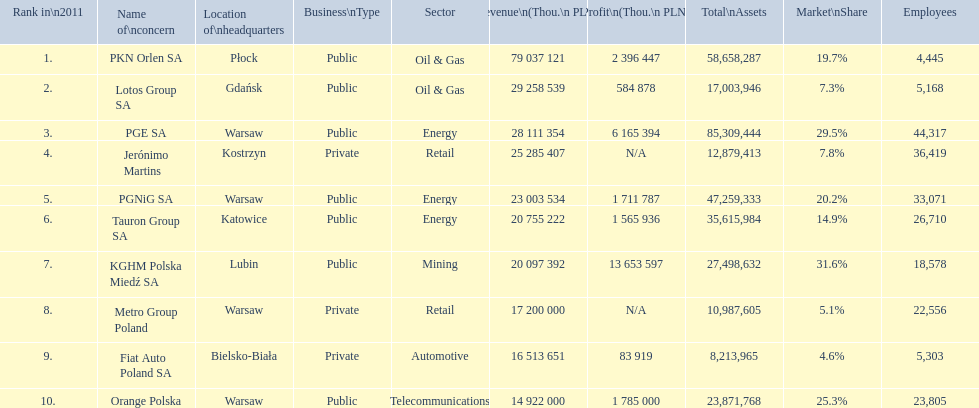What companies are listed? PKN Orlen SA, Lotos Group SA, PGE SA, Jerónimo Martins, PGNiG SA, Tauron Group SA, KGHM Polska Miedź SA, Metro Group Poland, Fiat Auto Poland SA, Orange Polska. What are the company's revenues? 79 037 121, 29 258 539, 28 111 354, 25 285 407, 23 003 534, 20 755 222, 20 097 392, 17 200 000, 16 513 651, 14 922 000. Which company has the greatest revenue? PKN Orlen SA. 